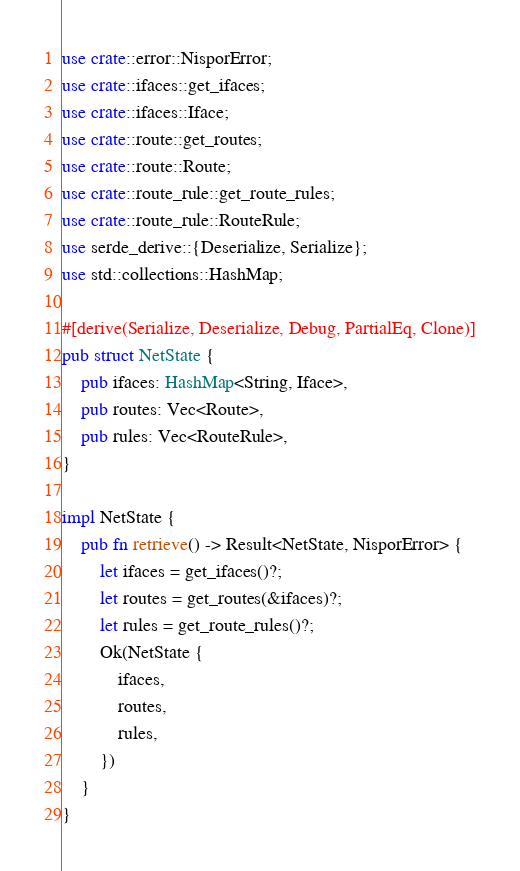Convert code to text. <code><loc_0><loc_0><loc_500><loc_500><_Rust_>use crate::error::NisporError;
use crate::ifaces::get_ifaces;
use crate::ifaces::Iface;
use crate::route::get_routes;
use crate::route::Route;
use crate::route_rule::get_route_rules;
use crate::route_rule::RouteRule;
use serde_derive::{Deserialize, Serialize};
use std::collections::HashMap;

#[derive(Serialize, Deserialize, Debug, PartialEq, Clone)]
pub struct NetState {
    pub ifaces: HashMap<String, Iface>,
    pub routes: Vec<Route>,
    pub rules: Vec<RouteRule>,
}

impl NetState {
    pub fn retrieve() -> Result<NetState, NisporError> {
        let ifaces = get_ifaces()?;
        let routes = get_routes(&ifaces)?;
        let rules = get_route_rules()?;
        Ok(NetState {
            ifaces,
            routes,
            rules,
        })
    }
}
</code> 